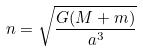<formula> <loc_0><loc_0><loc_500><loc_500>n = \sqrt { \frac { G ( M + m ) } { a ^ { 3 } } }</formula> 